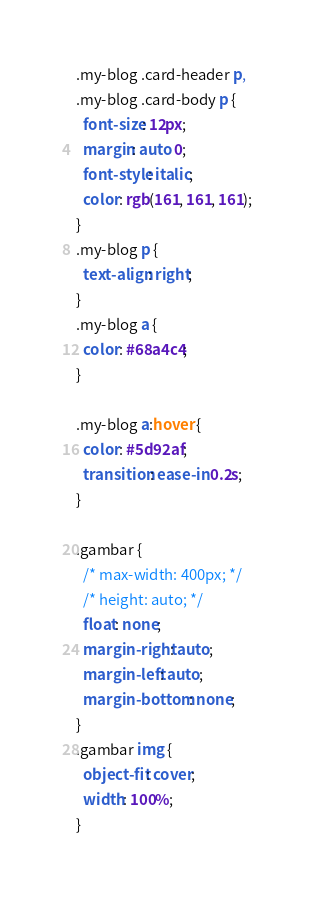<code> <loc_0><loc_0><loc_500><loc_500><_CSS_>.my-blog .card-header p,
.my-blog .card-body p {
  font-size: 12px;
  margin: auto 0;
  font-style: italic;
  color: rgb(161, 161, 161);
}
.my-blog p {
  text-align: right;
}
.my-blog a {
  color: #68a4c4;
}

.my-blog a:hover {
  color: #5d92af;
  transition: ease-in 0.2s;
}

.gambar {
  /* max-width: 400px; */
  /* height: auto; */
  float: none;
  margin-right: auto;
  margin-left: auto;
  margin-bottom: none;
}
.gambar img {
  object-fit: cover;
  width: 100%;
}
</code> 